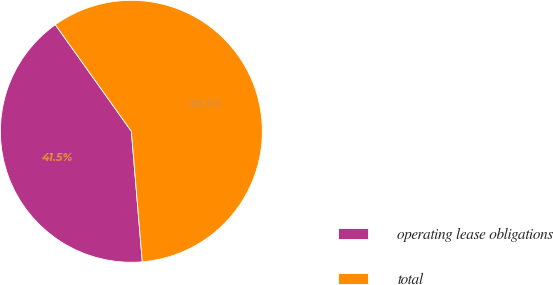<chart> <loc_0><loc_0><loc_500><loc_500><pie_chart><fcel>operating lease obligations<fcel>total<nl><fcel>41.47%<fcel>58.53%<nl></chart> 